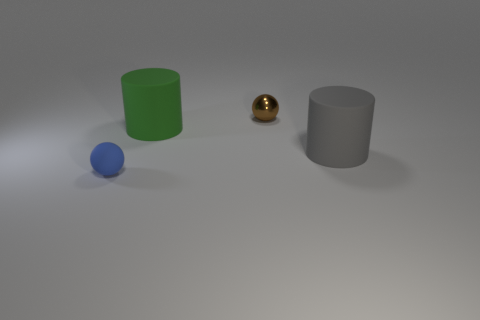Add 3 tiny brown balls. How many objects exist? 7 Subtract 1 spheres. How many spheres are left? 1 Subtract all brown balls. How many balls are left? 1 Add 3 green matte things. How many green matte things exist? 4 Subtract 1 brown balls. How many objects are left? 3 Subtract all yellow spheres. Subtract all blue cubes. How many spheres are left? 2 Subtract all purple blocks. How many brown balls are left? 1 Subtract all shiny things. Subtract all metal objects. How many objects are left? 2 Add 2 brown balls. How many brown balls are left? 3 